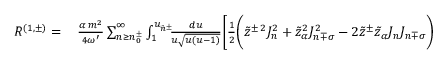<formula> <loc_0><loc_0><loc_500><loc_500>\begin{array} { r l } { R ^ { ( 1 , \pm ) } = } & \, \frac { \alpha \, m ^ { 2 } } { 4 \omega ^ { \prime } } \sum _ { n \geq n _ { 0 } ^ { \pm } } ^ { \infty } \int _ { 1 } ^ { u _ { \tilde { n } ^ { \pm } } } \, \frac { d u } { u \sqrt { u ( u - 1 ) } } \Big [ \frac { 1 } { 2 } \Big ( \tilde { z } ^ { \pm \, 2 } J _ { n } ^ { 2 } + \tilde { z } _ { \alpha } ^ { 2 } J _ { n \mp \sigma } ^ { 2 } - 2 \tilde { z } ^ { \pm } \tilde { z } _ { \alpha } J _ { n } J _ { n \mp \sigma } \Big ) } \end{array}</formula> 